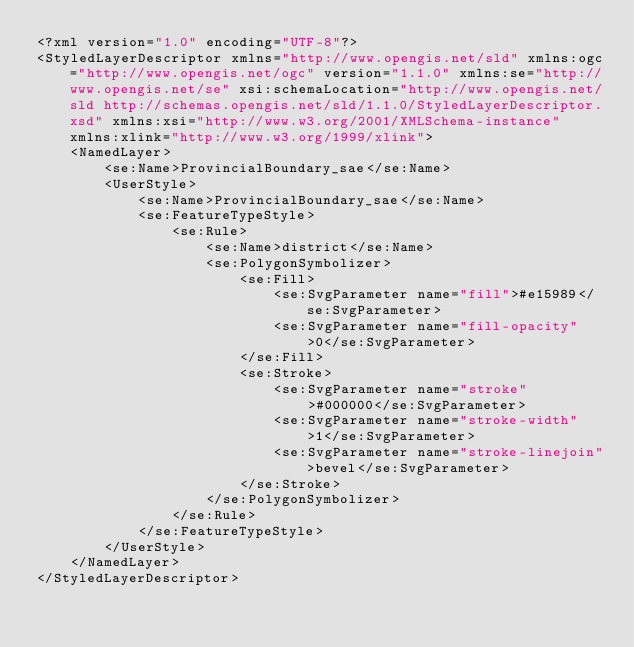Convert code to text. <code><loc_0><loc_0><loc_500><loc_500><_Scheme_><?xml version="1.0" encoding="UTF-8"?>
<StyledLayerDescriptor xmlns="http://www.opengis.net/sld" xmlns:ogc="http://www.opengis.net/ogc" version="1.1.0" xmlns:se="http://www.opengis.net/se" xsi:schemaLocation="http://www.opengis.net/sld http://schemas.opengis.net/sld/1.1.0/StyledLayerDescriptor.xsd" xmlns:xsi="http://www.w3.org/2001/XMLSchema-instance" xmlns:xlink="http://www.w3.org/1999/xlink">
    <NamedLayer>
        <se:Name>ProvincialBoundary_sae</se:Name>
        <UserStyle>
            <se:Name>ProvincialBoundary_sae</se:Name>
            <se:FeatureTypeStyle>
                <se:Rule>
                    <se:Name>district</se:Name>
                    <se:PolygonSymbolizer>
                        <se:Fill>
                            <se:SvgParameter name="fill">#e15989</se:SvgParameter>
                            <se:SvgParameter name="fill-opacity">0</se:SvgParameter>
                        </se:Fill>
                        <se:Stroke>
                            <se:SvgParameter name="stroke">#000000</se:SvgParameter>
                            <se:SvgParameter name="stroke-width">1</se:SvgParameter>
                            <se:SvgParameter name="stroke-linejoin">bevel</se:SvgParameter>
                        </se:Stroke>
                    </se:PolygonSymbolizer>
                </se:Rule>
            </se:FeatureTypeStyle>
        </UserStyle>
    </NamedLayer>
</StyledLayerDescriptor>
</code> 